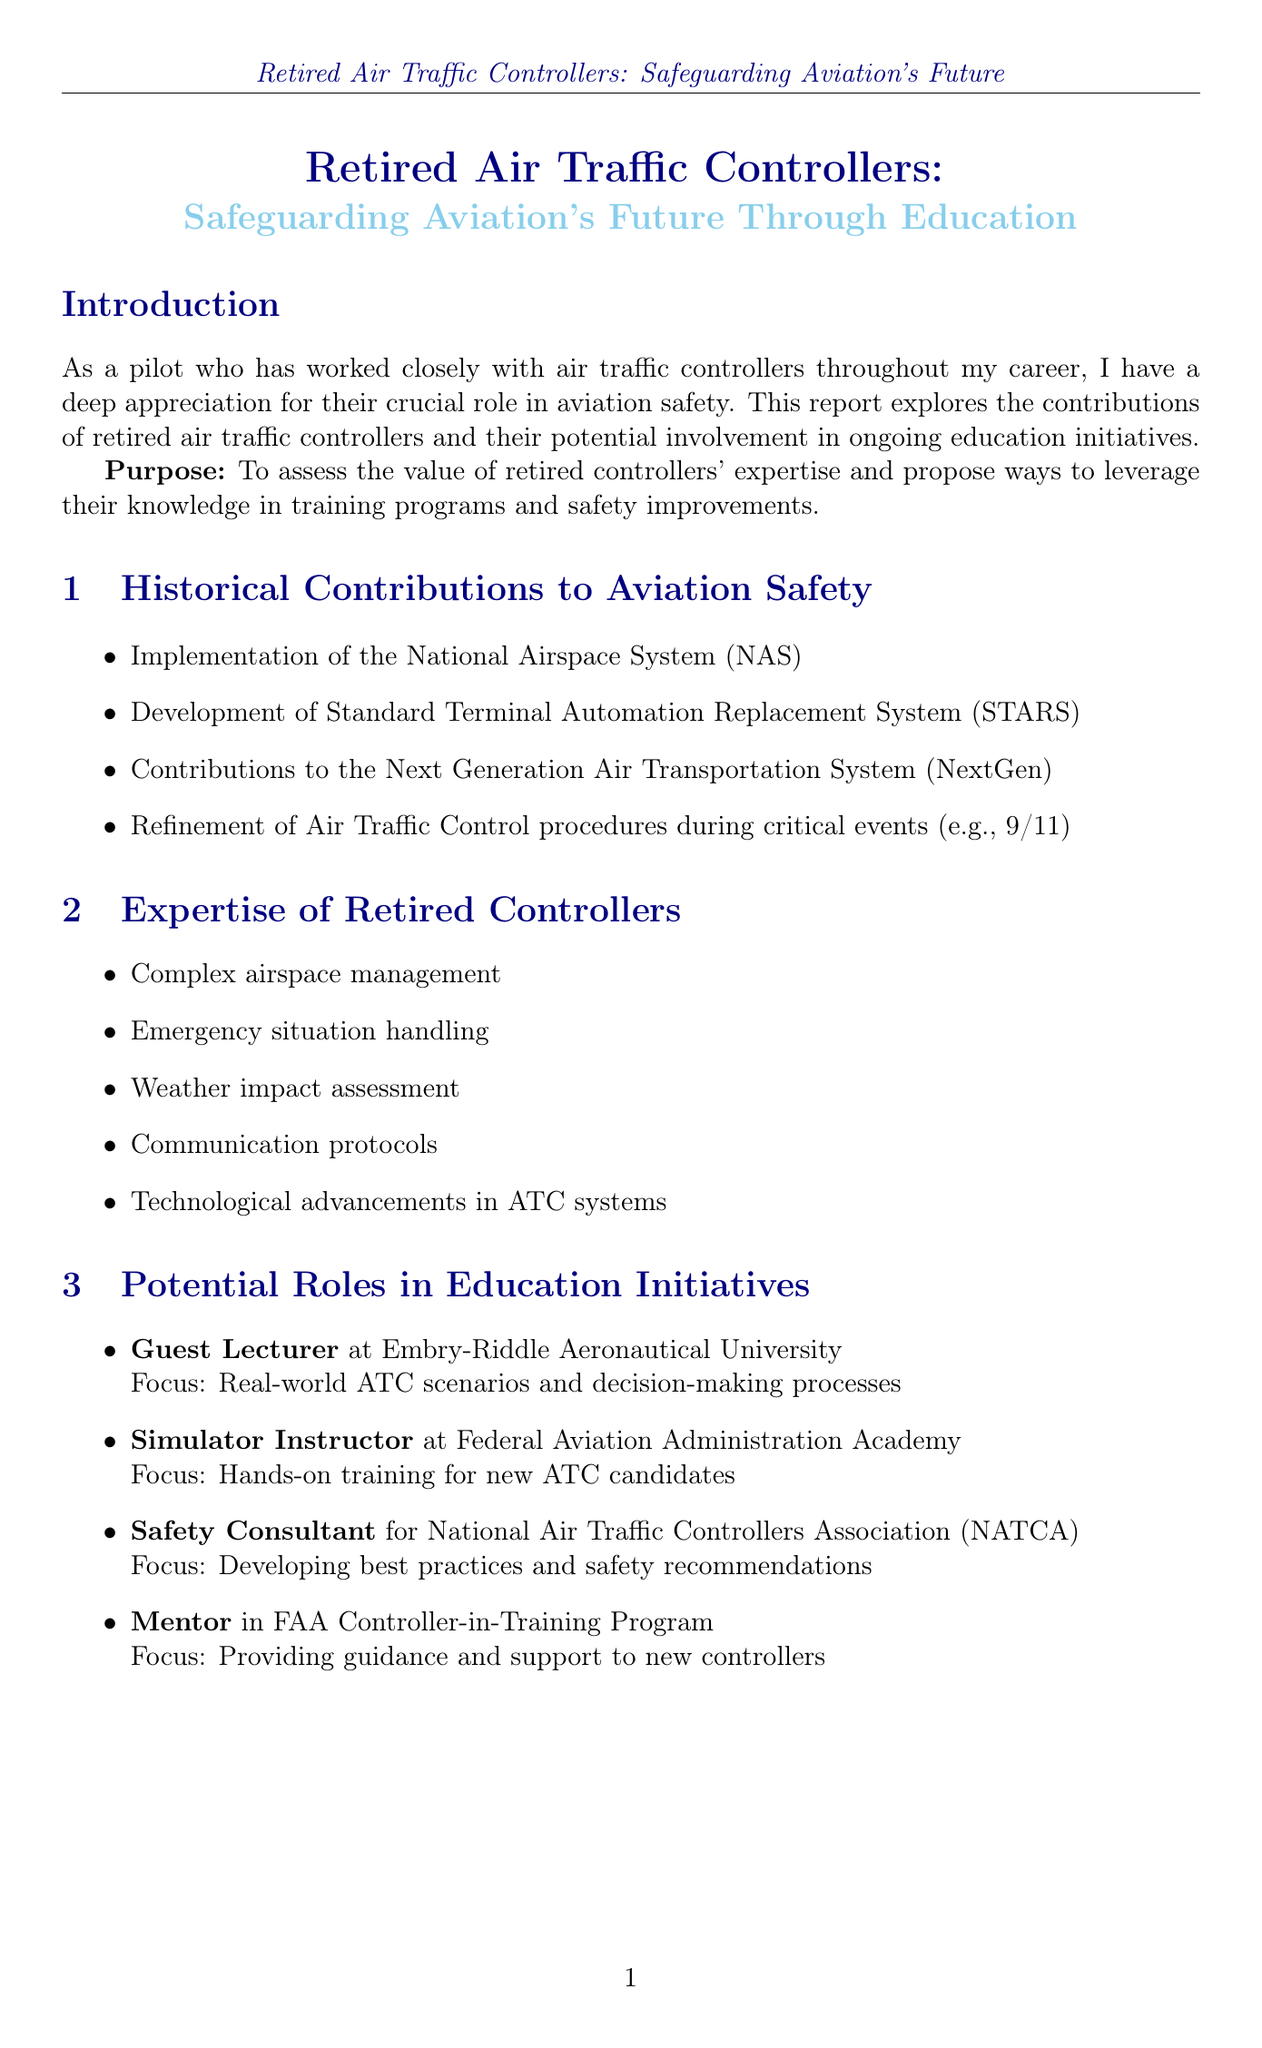What is the title of the report? The title of the report is stated at the beginning of the document.
Answer: Retired Air Traffic Controllers: Safeguarding Aviation's Future Through Education How many years of experience does John O'Donnell have? John O'Donnell's experience is detailed in the case studies section of the document.
Answer: 35 years What position is suggested for retired controllers at Embry-Riddle Aeronautical University? The document lists potential roles for retired controllers specifically at Embry-Riddle.
Answer: Guest Lecturer What is one benefit of involving retired controllers in education? The benefits are outlined in a designated section, explaining the advantages of retired controllers' involvement.
Answer: Bridging the gap between theoretical knowledge and practical experience What challenge is mentioned concerning retired controllers' training? The challenges faced when engaging retired controllers are listed clearly in their own section.
Answer: Keeping retired controllers updated on current technologies and procedures What kind of training program is suggested to pair retired controllers with students? This suggestion is one of the recommendations made within the document for better education initiatives.
Answer: Mentorship program How many roles are listed in the Education Initiatives section? The potential roles are enumerated in a list, providing a count of the available options.
Answer: Four roles What significant event is mentioned in the historical contributions section? The document refers to a specific incident that shaped air traffic control procedures.
Answer: 9/11 